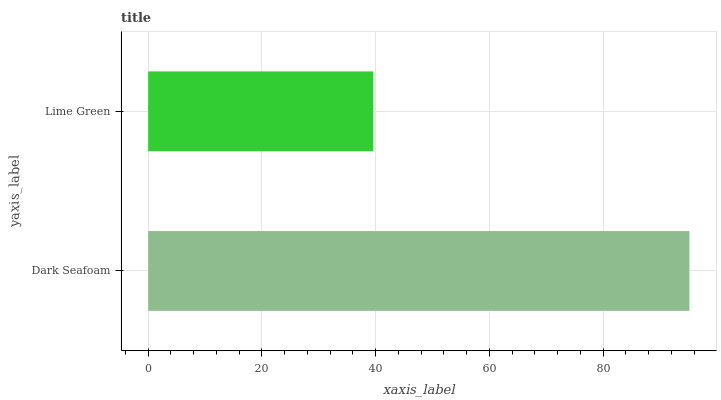Is Lime Green the minimum?
Answer yes or no. Yes. Is Dark Seafoam the maximum?
Answer yes or no. Yes. Is Lime Green the maximum?
Answer yes or no. No. Is Dark Seafoam greater than Lime Green?
Answer yes or no. Yes. Is Lime Green less than Dark Seafoam?
Answer yes or no. Yes. Is Lime Green greater than Dark Seafoam?
Answer yes or no. No. Is Dark Seafoam less than Lime Green?
Answer yes or no. No. Is Dark Seafoam the high median?
Answer yes or no. Yes. Is Lime Green the low median?
Answer yes or no. Yes. Is Lime Green the high median?
Answer yes or no. No. Is Dark Seafoam the low median?
Answer yes or no. No. 